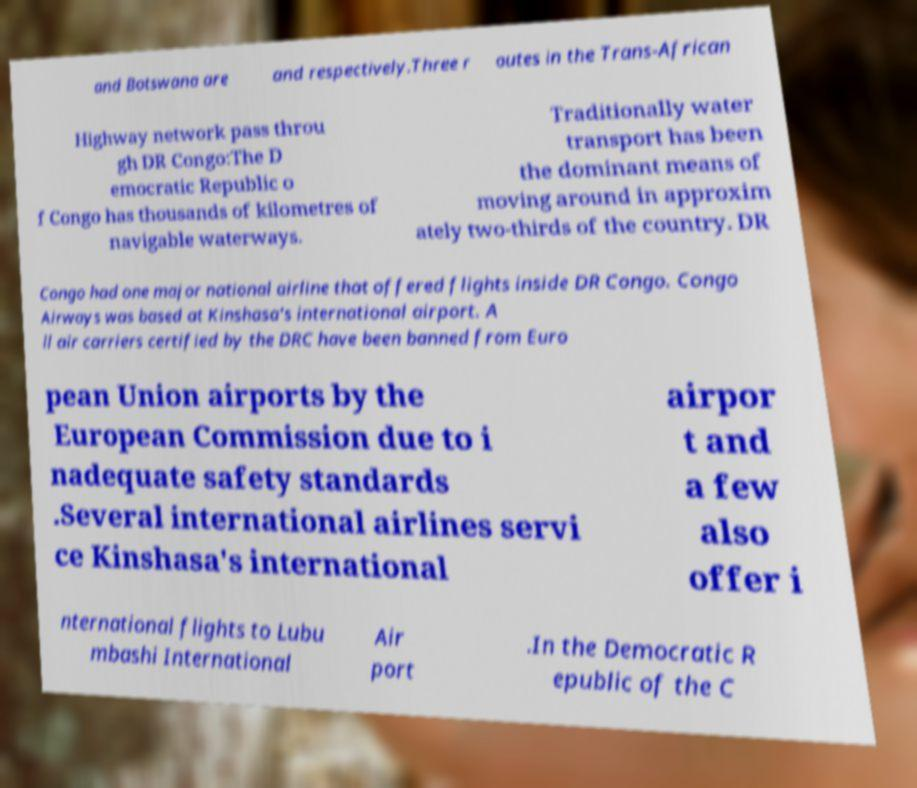Can you accurately transcribe the text from the provided image for me? and Botswana are and respectively.Three r outes in the Trans-African Highway network pass throu gh DR Congo:The D emocratic Republic o f Congo has thousands of kilometres of navigable waterways. Traditionally water transport has been the dominant means of moving around in approxim ately two-thirds of the country. DR Congo had one major national airline that offered flights inside DR Congo. Congo Airways was based at Kinshasa's international airport. A ll air carriers certified by the DRC have been banned from Euro pean Union airports by the European Commission due to i nadequate safety standards .Several international airlines servi ce Kinshasa's international airpor t and a few also offer i nternational flights to Lubu mbashi International Air port .In the Democratic R epublic of the C 